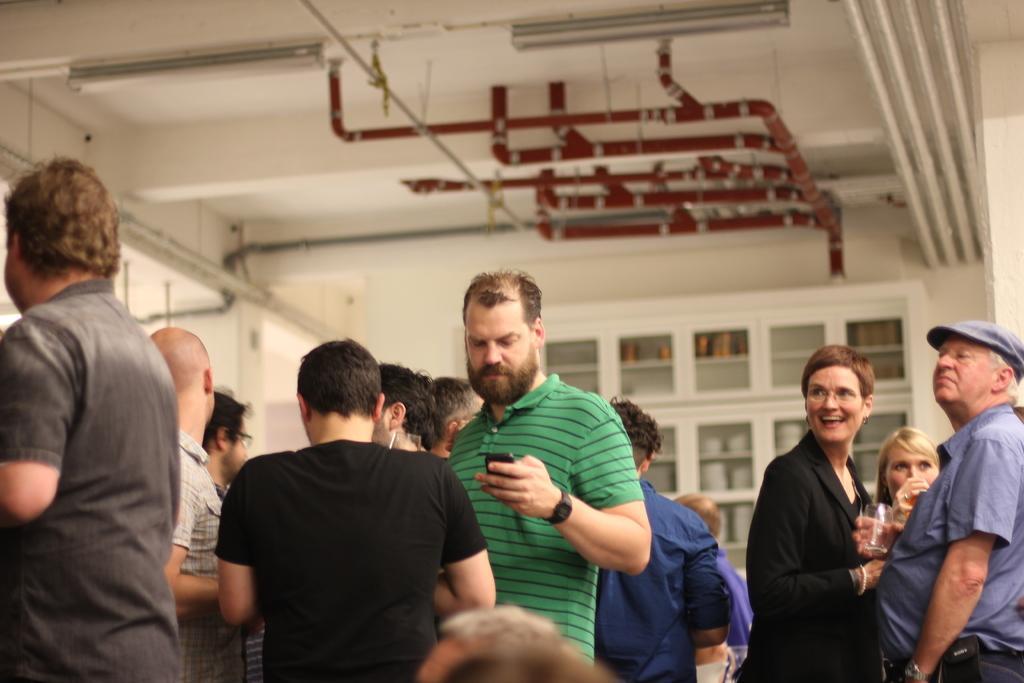Describe this image in one or two sentences. In this picture we can see a group of people, two men are holding glasses and a device with their hands. In the background we can see the wall, ceiling, pipes and shelves with some objects on it. 